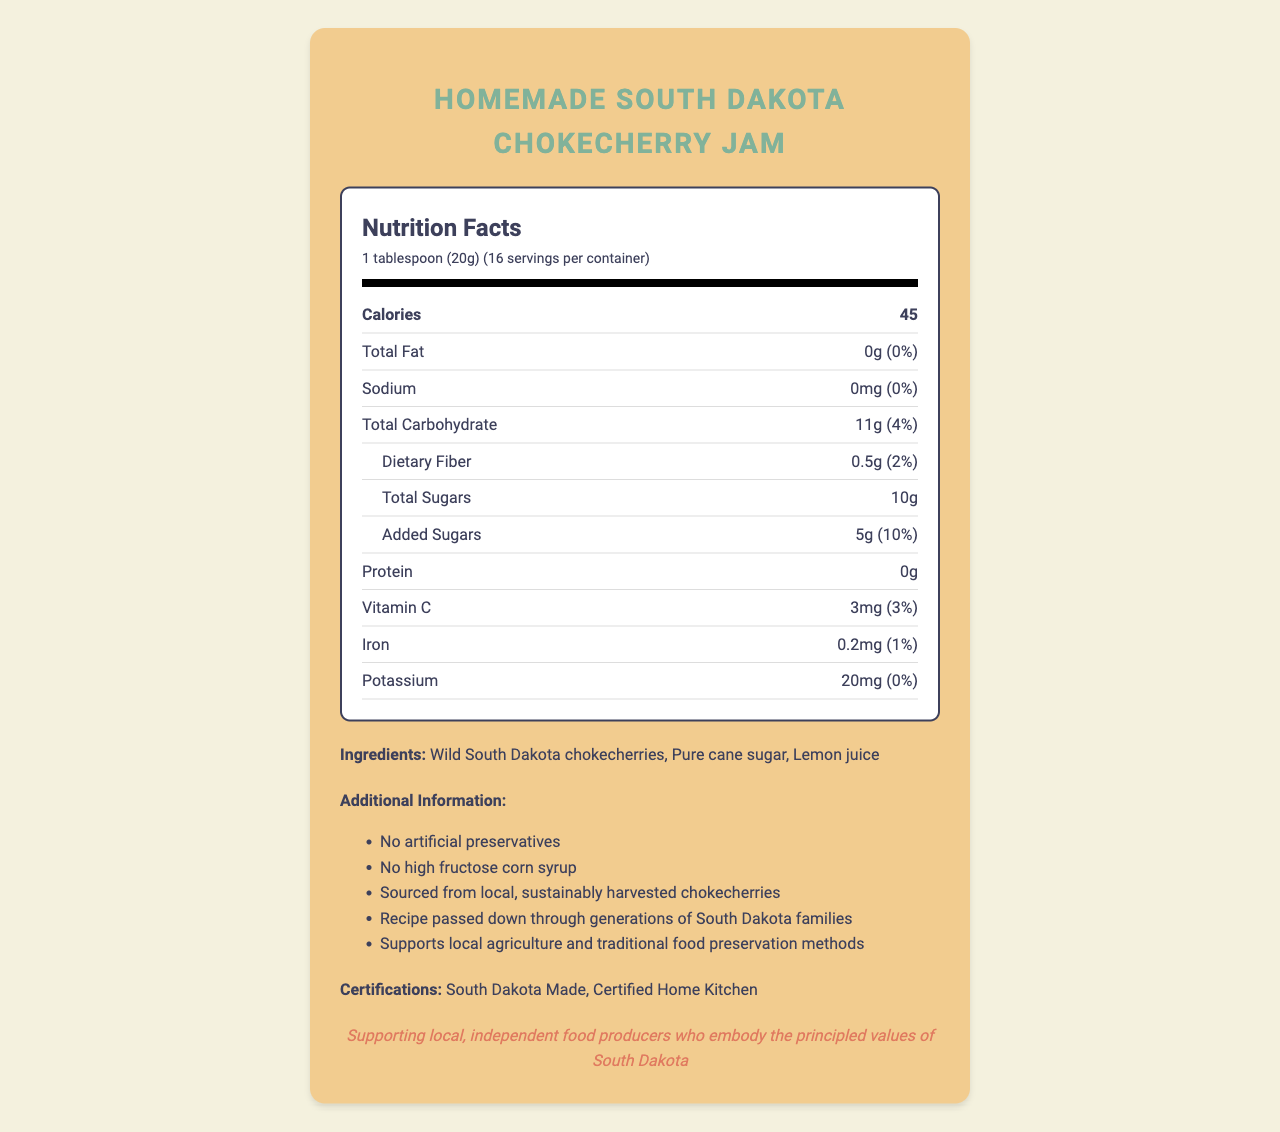what is the serving size? The serving size is mentioned at the beginning of the nutrition facts, specifying "1 tablespoon (20g)".
Answer: 1 tablespoon (20g) how many calories are in one serving? The document states that there are 45 calories per serving.
Answer: 45 what are the total carbohydrates per serving? The total carbohydrate content per serving is listed as 11g.
Answer: 11g what is the amount of total sugars in one serving? The total sugars per serving is listed at 10g.
Answer: 10g who made the jam? The producer information indicates that the jam is made by the Johnson Family from Rapid City, SD.
Answer: The Johnson Family, Rapid City, SD 57701 which of the following is NOT an ingredient listed on the label? A. Pure cane sugar B. Wild South Dakota chokecherries C. High fructose corn syrup D. Lemon juice The ingredients listed are Wild South Dakota chokecherries, Pure cane sugar, and Lemon juice. High fructose corn syrup is noted as not being used in the jam.
Answer: C. High fructose corn syrup how many servings are in the container? The document mentions that there are 16 servings per container.
Answer: 16 what is the daily value percentage of added sugars in one serving? The daily value percentage of added sugars per serving is listed as 10%.
Answer: 10% does the jam contain any preservatives? The document explicitly states "No artificial preservatives" in the additional information section.
Answer: No what is the main political statement mentioned? The political statement is found at the end of the document, supporting local, independent food producers.
Answer: Supporting local, independent food producers who embody the principled values of South Dakota describe the certifications the jam has received. The certifications section lists "South Dakota Made" and "Certified Home Kitchen."
Answer: The jam is certified as South Dakota Made and Certified Home Kitchen. summarize the key attributes of the Homemade South Dakota Chokecherry Jam. This summary covers the ingredients, nutritional content, additional information, certifications, and the producer of the jam.
Answer: The Homemade South Dakota Chokecherry Jam is made by the Johnson Family from Rapid City, SD, and contains no artificial preservatives or high fructose corn syrup. It has 45 calories, 11g of carbohydrates, and 10g of sugars per 1 tablespoon (20g) serving. The ingredients are Wild South Dakota chokecherries, Pure cane sugar, and Lemon juice. The product supports local agriculture and traditional food preservation methods and is certified as South Dakota Made and Certified Home Kitchen. how much dietary fiber is there per serving? The amount of dietary fiber per serving is listed as 0.5g.
Answer: 0.5g what is the daily value of sodium per serving? The document states that the daily value percentage of sodium per serving is 0%.
Answer: 0% which of the following is a nutrient content claim made on the label? A. High in Protein B. Low sodium C. High in Iron The document lists "Low sodium" as one of the nutrient content claims.
Answer: B. Low sodium is this jam a good source of vitamin C? The document claims that the jam is a good source of vitamin C.
Answer: Yes does the document provide details on how to prepare the jam? The document does not provide any preparation instructions; it only includes the nutritional facts and additional product information.
Answer: Cannot be determined 